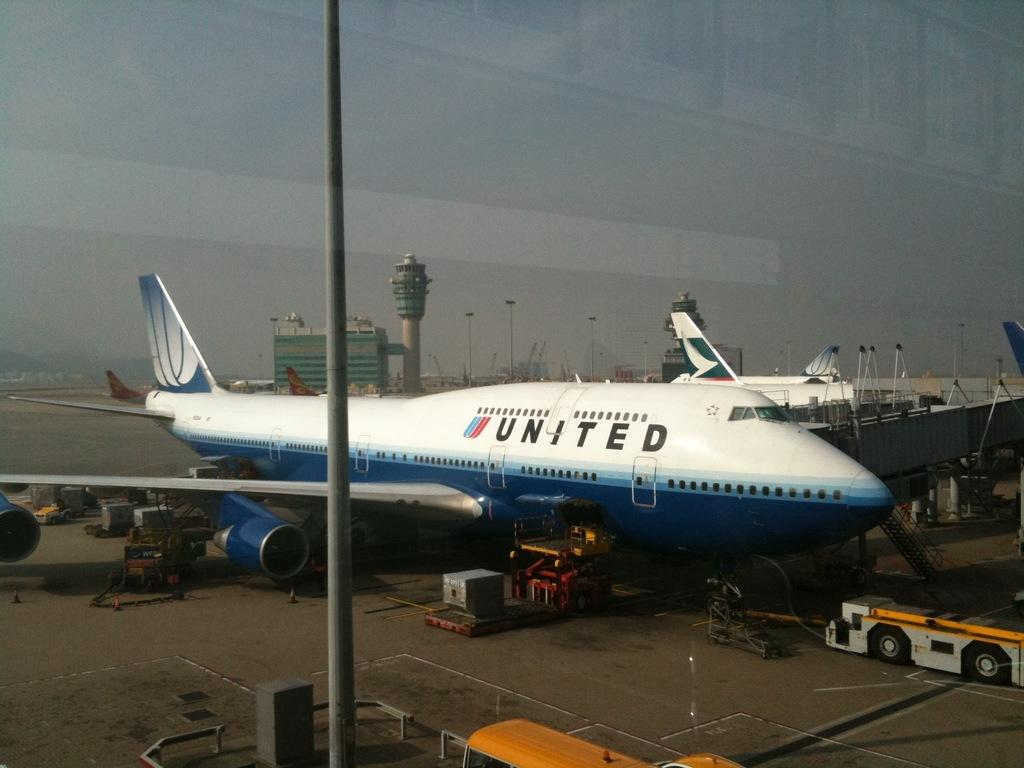<image>
Give a short and clear explanation of the subsequent image. A United Airlines Flight can be seen loading luggage onto the plane at the terminal 